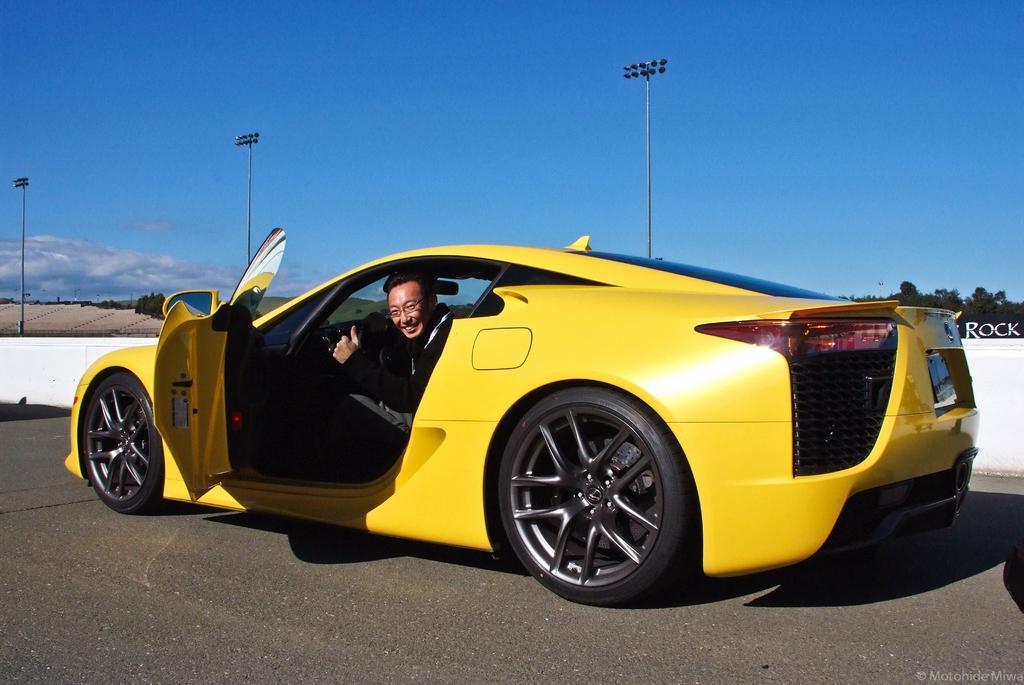Describe this image in one or two sentences. This is an outside view. Here I can see a yellow color car on the road. Inside the car there is a man sitting, smiling and giving pose for the picture. In the background there are some poles and trees. Beside the car there is a white color wall. On the top of the image I can see the sky. 